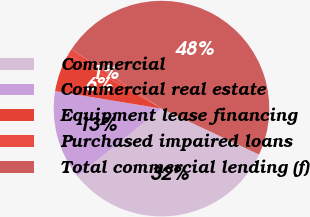Convert chart to OTSL. <chart><loc_0><loc_0><loc_500><loc_500><pie_chart><fcel>Commercial<fcel>Commercial real estate<fcel>Equipment lease financing<fcel>Purchased impaired loans<fcel>Total commercial lending (f)<nl><fcel>32.24%<fcel>13.37%<fcel>5.67%<fcel>1.0%<fcel>47.73%<nl></chart> 